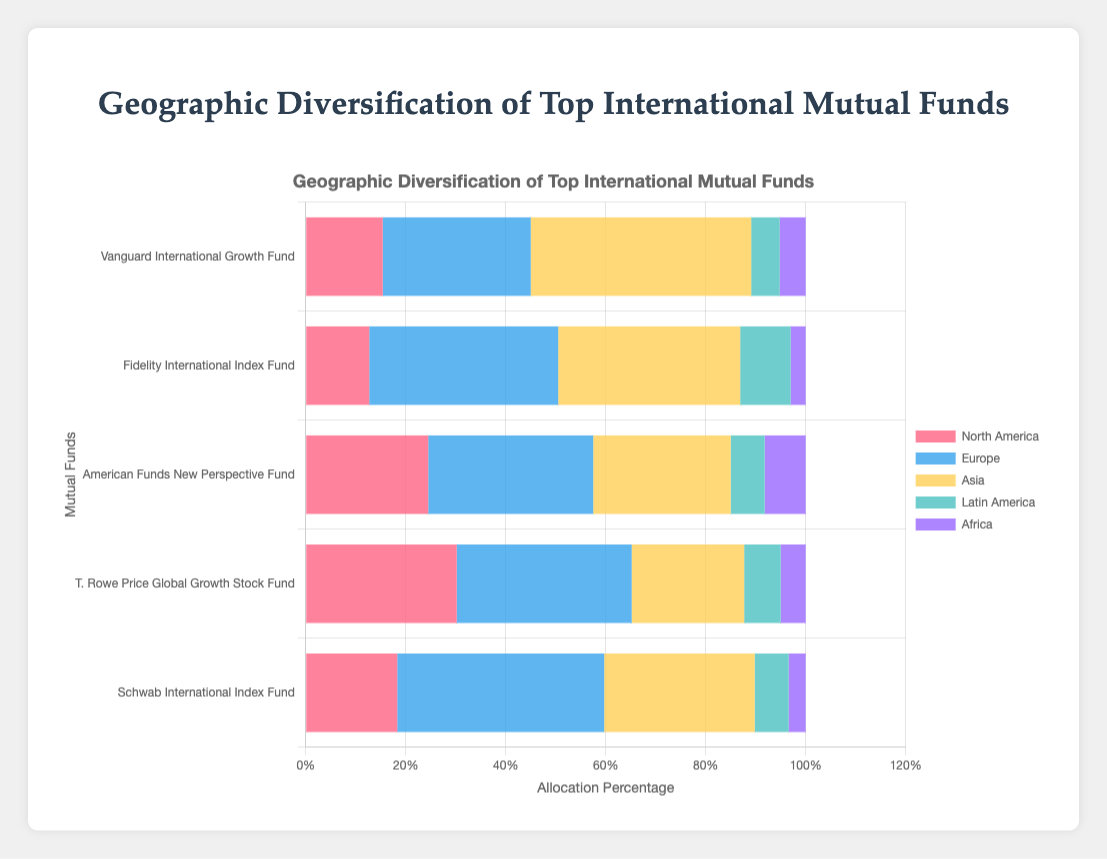How much higher is the allocation to Asia in the Vanguard International Growth Fund compared to the Schwab International Index Fund? The allocation to Asia in the Vanguard International Growth Fund is 44.1%, while in the Schwab International Index Fund it is 30.1%. The difference is calculated as 44.1 - 30.1 = 14.0.
Answer: 14.0% Which fund has the highest allocation to Europe? By looking at the European allocation bars, the Schwab International Index Fund has the highest allocation at 41.4%.
Answer: Schwab International Index Fund What's the total allocation percentage of North America and Europe in the American Funds New Perspective Fund? North America has a 24.5% allocation and Europe has a 33.0% allocation. Summing them, 24.5 + 33.0 = 57.5.
Answer: 57.5% Which region has the smallest allocation across all funds? By checking the smallest bars in each category, Africa appears to have the smallest allocations. The smallest value is 3.0% in the Fidelity International Index Fund.
Answer: Africa Compare the allocation to Latin America between the Fidelity International Index Fund and the T. Rowe Price Global Growth Stock Fund. Which one allocates more, and by how much? Fidelity International Index Fund allocates 10.1% to Latin America, while T. Rowe Price Global Growth Stock Fund allocates 7.3%. The difference is 10.1 - 7.3 = 2.8.
Answer: Fidelity International Index Fund, by 2.8% Which fund has the largest variability in its regional allocations? Examining the spread of allocation values in each fund shows the American Funds New Perspective Fund has allocations ranging widely from 8.2% (Africa) to 33.0% (Europe).
Answer: American Funds New Perspective Fund What is the average allocation to Asia across all funds? Add the Asia allocations for all funds: 44.1% (Vanguard) + 36.4% (Fidelity) + 27.5% (American Funds) + 22.5% (T. Rowe Price) + 30.1% (Schwab) = 160.6%. Divide by 5 funds: 160.6 / 5 = 32.12.
Answer: 32.12% Identify the fund with the second highest allocation to North America. The allocations to North America are 15.4% (Vanguard), 12.7% (Fidelity), 24.5% (American Funds), 30.2% (T. Rowe Price), and 18.3% (Schwab). The second highest after 30.2% is 24.5%.
Answer: American Funds New Perspective Fund What is the combined allocation for African and Latin American regions in the T. Rowe Price Global Growth Stock Fund? Latin American allocation is 7.3% and African allocation is 5.0%. Combined allocation is 7.3 + 5.0 = 12.3.
Answer: 12.3% How does the total percentage allocation for Europe compare among all the funds? The Europe allocations are 29.6% (Vanguard), 37.8% (Fidelity), 33.0% (American Funds), 35.0% (T. Rowe Price), 41.4% (Schwab). Schwab has the highest allocation among them.
Answer: Schwab International Index Fund 